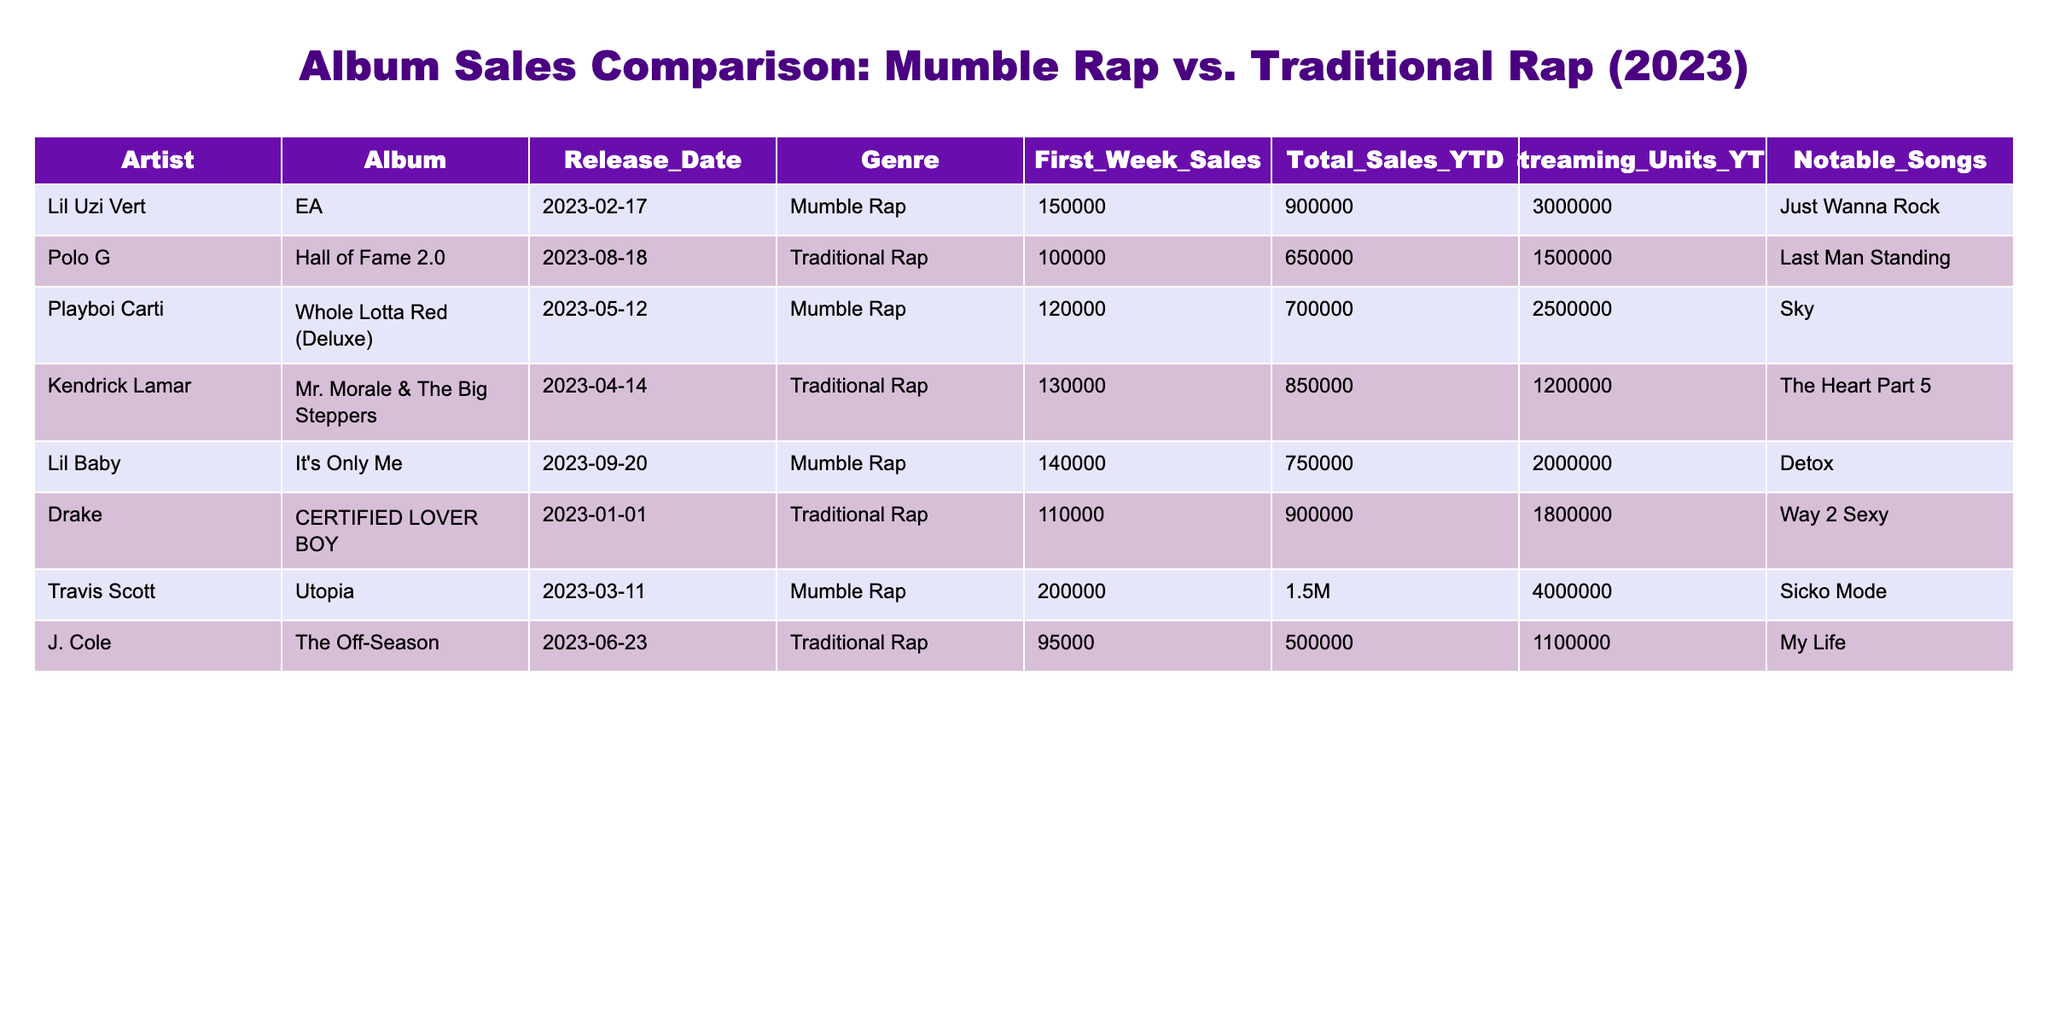What is the total sales YTD for the album "EA" by Lil Uzi Vert? Looking at the row for Lil Uzi Vert, the column "Total_Sales_YTD" states that the total sales for "EA" is 900000.
Answer: 900000 What was the first week sales for Kendrick Lamar's album? In the row for Kendrick Lamar, the column "First_Week_Sales" indicates that the first week sales were 130000 units.
Answer: 130000 How many albums had first week sales greater than 140000? I will review the "First_Week_Sales" column: Lil Uzi Vert (150000), Playboi Carti (120000), Lil Baby (140000), and Travis Scott (200000). Only Lil Uzi Vert and Travis Scott had first week sales greater than 140000. So, 2 albums qualify.
Answer: 2 Is "Last Man Standing" by Polo G associated with mumble rap? By checking the "Genre" for Polo G's album, it is listed as "Traditional Rap," which means it is not classified as mumble rap.
Answer: No Which genre had the highest total sales YTD? Totalling YTD sales for each genre: Mumble Rap totals (900000 + 700000 + 750000 + 1500000 = 3075000), Traditional Rap totals (650000 + 850000 + 900000 + 500000 = 2900000). The total for Mumble Rap (3075000) is higher than Traditional Rap (2900000). Thus, Mumble Rap has the highest sales YTD.
Answer: Mumble Rap What is the streaming units YTD for Lil Baby's album? According to the row for Lil Baby, the column "Streaming_Units_YTD" lists 2000000 as the streaming units for "It's Only Me."
Answer: 2000000 How many notable songs are listed for Traditional Rap albums? From the albums classified under Traditional Rap (Polo G, Kendrick Lamar, Drake, J. Cole), each has one notable song mentioned, making it a total of 4 notable songs.
Answer: 4 What is the average total sales YTD for Mumble Rap albums? The total YTD sales for Mumble Rap albums are 900000 (Lil Uzi Vert) + 700000 (Playboi Carti) + 750000 (Lil Baby) + 1500000 (Travis Scott) = 3075000. There are 4 Mumble Rap albums, so dividing 3075000 by 4 gives us an average of 768750.
Answer: 768750 Which album had the lowest first week sales and what was the value? First, I will list the first week sales: Lil Uzi Vert (150000), Polo G (100000), Playboi Carti (120000), Kendrick Lamar (130000), Lil Baby (140000), Drake (110000), Travis Scott (200000), J. Cole (95000). The lowest sales are 95000 for J. Cole's album "The Off-Season."
Answer: 95000 